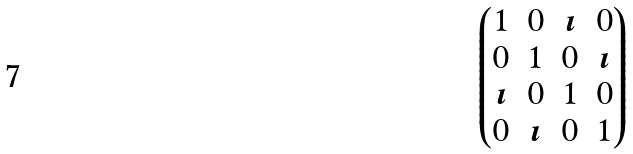<formula> <loc_0><loc_0><loc_500><loc_500>\begin{pmatrix} 1 & 0 & \imath & 0 \\ 0 & 1 & 0 & \imath \\ \imath & 0 & 1 & 0 \\ 0 & \imath & 0 & 1 \end{pmatrix}</formula> 